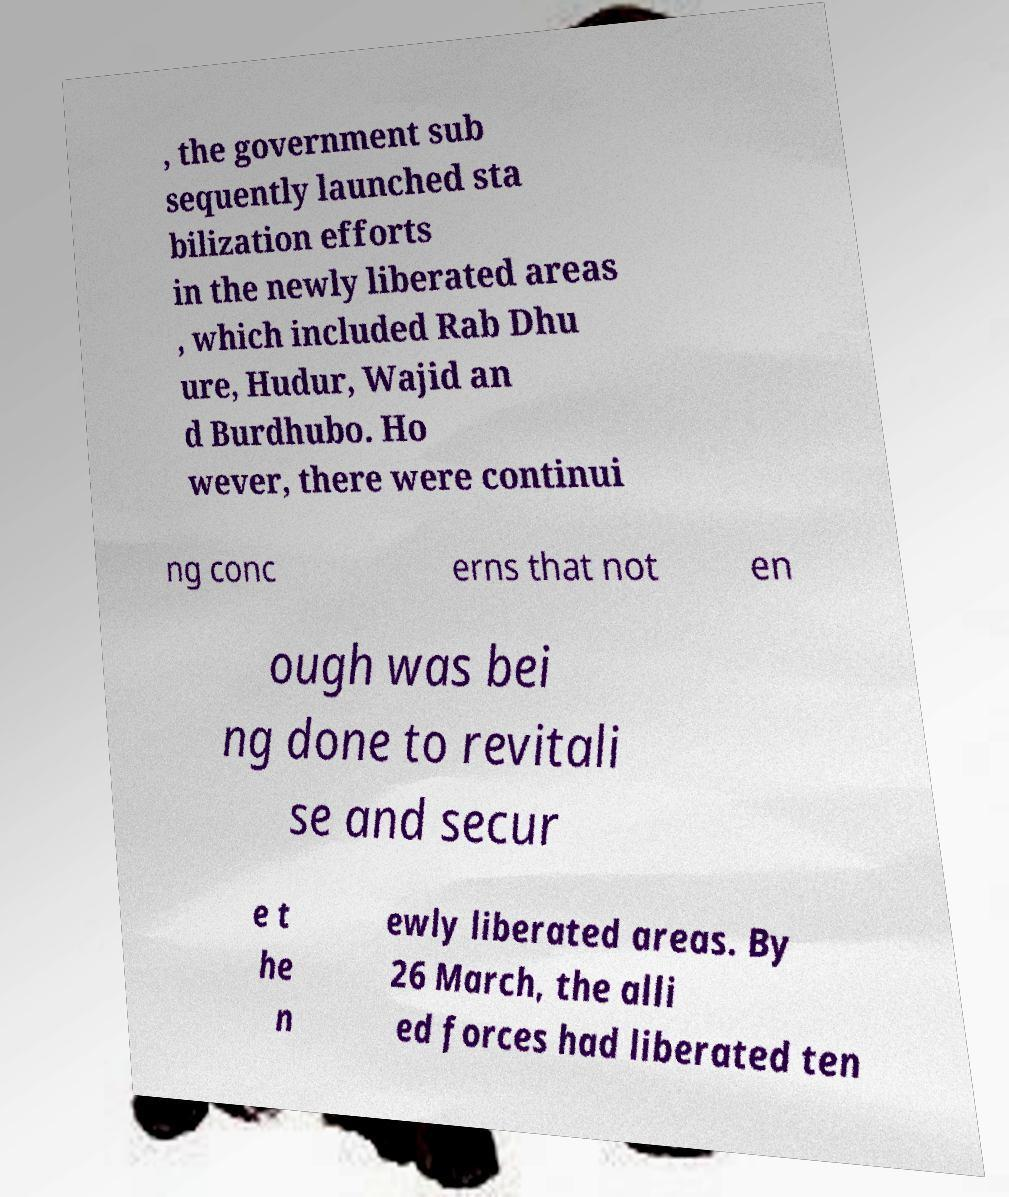What messages or text are displayed in this image? I need them in a readable, typed format. , the government sub sequently launched sta bilization efforts in the newly liberated areas , which included Rab Dhu ure, Hudur, Wajid an d Burdhubo. Ho wever, there were continui ng conc erns that not en ough was bei ng done to revitali se and secur e t he n ewly liberated areas. By 26 March, the alli ed forces had liberated ten 